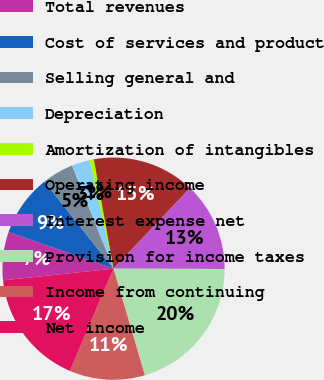Convert chart. <chart><loc_0><loc_0><loc_500><loc_500><pie_chart><fcel>Total revenues<fcel>Cost of services and product<fcel>Selling general and<fcel>Depreciation<fcel>Amortization of intangibles<fcel>Operating income<fcel>Interest expense net<fcel>Provision for income taxes<fcel>Income from continuing<fcel>Net income<nl><fcel>7.02%<fcel>8.99%<fcel>4.59%<fcel>2.61%<fcel>0.64%<fcel>14.92%<fcel>12.95%<fcel>20.41%<fcel>10.97%<fcel>16.9%<nl></chart> 